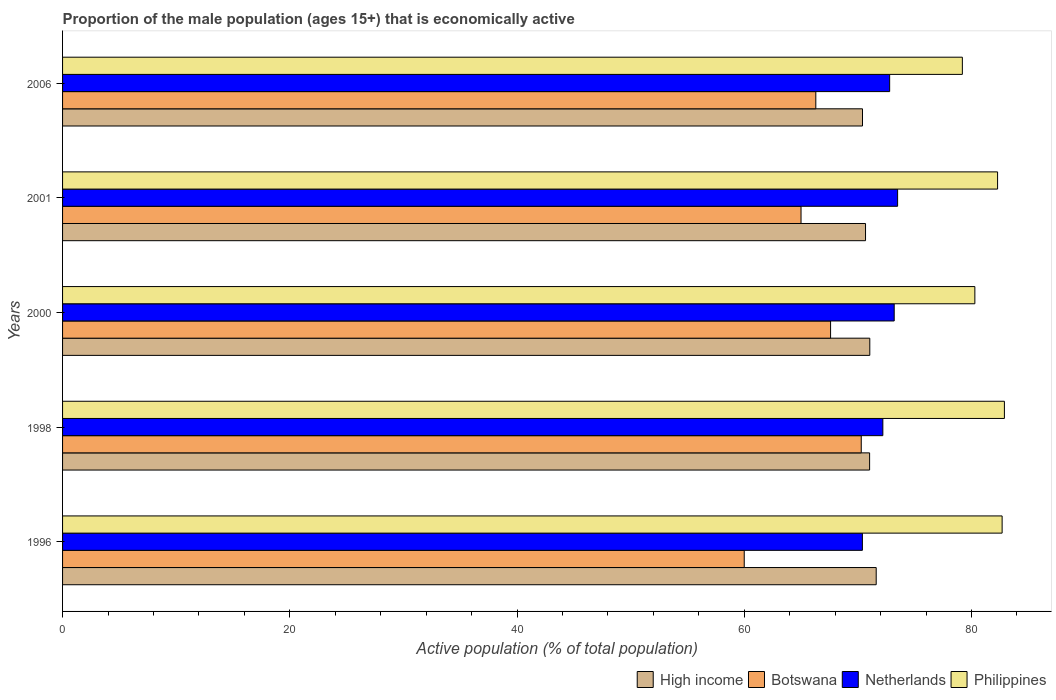How many different coloured bars are there?
Offer a terse response. 4. Are the number of bars per tick equal to the number of legend labels?
Offer a very short reply. Yes. How many bars are there on the 4th tick from the bottom?
Keep it short and to the point. 4. In how many cases, is the number of bars for a given year not equal to the number of legend labels?
Make the answer very short. 0. Across all years, what is the maximum proportion of the male population that is economically active in Philippines?
Offer a very short reply. 82.9. Across all years, what is the minimum proportion of the male population that is economically active in Netherlands?
Ensure brevity in your answer.  70.4. In which year was the proportion of the male population that is economically active in High income minimum?
Your answer should be compact. 2006. What is the total proportion of the male population that is economically active in Philippines in the graph?
Ensure brevity in your answer.  407.4. What is the difference between the proportion of the male population that is economically active in Philippines in 2000 and that in 2001?
Give a very brief answer. -2. What is the difference between the proportion of the male population that is economically active in Botswana in 2000 and the proportion of the male population that is economically active in Netherlands in 2001?
Make the answer very short. -5.9. What is the average proportion of the male population that is economically active in Botswana per year?
Provide a succinct answer. 65.84. In the year 2006, what is the difference between the proportion of the male population that is economically active in Botswana and proportion of the male population that is economically active in High income?
Offer a very short reply. -4.11. In how many years, is the proportion of the male population that is economically active in Botswana greater than 64 %?
Your answer should be compact. 4. What is the ratio of the proportion of the male population that is economically active in Botswana in 2000 to that in 2001?
Provide a succinct answer. 1.04. Is the proportion of the male population that is economically active in High income in 1998 less than that in 2006?
Your response must be concise. No. What is the difference between the highest and the second highest proportion of the male population that is economically active in Botswana?
Give a very brief answer. 2.7. What is the difference between the highest and the lowest proportion of the male population that is economically active in High income?
Ensure brevity in your answer.  1.21. In how many years, is the proportion of the male population that is economically active in Netherlands greater than the average proportion of the male population that is economically active in Netherlands taken over all years?
Give a very brief answer. 3. Is the sum of the proportion of the male population that is economically active in High income in 1998 and 2006 greater than the maximum proportion of the male population that is economically active in Philippines across all years?
Provide a short and direct response. Yes. Is it the case that in every year, the sum of the proportion of the male population that is economically active in Botswana and proportion of the male population that is economically active in High income is greater than the sum of proportion of the male population that is economically active in Philippines and proportion of the male population that is economically active in Netherlands?
Keep it short and to the point. No. What does the 1st bar from the top in 2000 represents?
Keep it short and to the point. Philippines. Are all the bars in the graph horizontal?
Make the answer very short. Yes. How many years are there in the graph?
Make the answer very short. 5. Are the values on the major ticks of X-axis written in scientific E-notation?
Your answer should be very brief. No. Does the graph contain any zero values?
Make the answer very short. No. Where does the legend appear in the graph?
Keep it short and to the point. Bottom right. How many legend labels are there?
Keep it short and to the point. 4. How are the legend labels stacked?
Ensure brevity in your answer.  Horizontal. What is the title of the graph?
Ensure brevity in your answer.  Proportion of the male population (ages 15+) that is economically active. What is the label or title of the X-axis?
Ensure brevity in your answer.  Active population (% of total population). What is the Active population (% of total population) in High income in 1996?
Your response must be concise. 71.62. What is the Active population (% of total population) in Botswana in 1996?
Offer a very short reply. 60. What is the Active population (% of total population) of Netherlands in 1996?
Provide a short and direct response. 70.4. What is the Active population (% of total population) of Philippines in 1996?
Make the answer very short. 82.7. What is the Active population (% of total population) of High income in 1998?
Provide a succinct answer. 71.04. What is the Active population (% of total population) in Botswana in 1998?
Your answer should be very brief. 70.3. What is the Active population (% of total population) in Netherlands in 1998?
Give a very brief answer. 72.2. What is the Active population (% of total population) in Philippines in 1998?
Offer a very short reply. 82.9. What is the Active population (% of total population) of High income in 2000?
Offer a terse response. 71.05. What is the Active population (% of total population) in Botswana in 2000?
Give a very brief answer. 67.6. What is the Active population (% of total population) in Netherlands in 2000?
Keep it short and to the point. 73.2. What is the Active population (% of total population) of Philippines in 2000?
Provide a short and direct response. 80.3. What is the Active population (% of total population) of High income in 2001?
Make the answer very short. 70.68. What is the Active population (% of total population) of Netherlands in 2001?
Your response must be concise. 73.5. What is the Active population (% of total population) in Philippines in 2001?
Your answer should be very brief. 82.3. What is the Active population (% of total population) of High income in 2006?
Offer a terse response. 70.41. What is the Active population (% of total population) of Botswana in 2006?
Your answer should be compact. 66.3. What is the Active population (% of total population) in Netherlands in 2006?
Your response must be concise. 72.8. What is the Active population (% of total population) of Philippines in 2006?
Your answer should be very brief. 79.2. Across all years, what is the maximum Active population (% of total population) of High income?
Keep it short and to the point. 71.62. Across all years, what is the maximum Active population (% of total population) of Botswana?
Your answer should be compact. 70.3. Across all years, what is the maximum Active population (% of total population) in Netherlands?
Your response must be concise. 73.5. Across all years, what is the maximum Active population (% of total population) of Philippines?
Your answer should be compact. 82.9. Across all years, what is the minimum Active population (% of total population) in High income?
Offer a very short reply. 70.41. Across all years, what is the minimum Active population (% of total population) in Botswana?
Make the answer very short. 60. Across all years, what is the minimum Active population (% of total population) in Netherlands?
Your answer should be compact. 70.4. Across all years, what is the minimum Active population (% of total population) in Philippines?
Your answer should be very brief. 79.2. What is the total Active population (% of total population) of High income in the graph?
Make the answer very short. 354.79. What is the total Active population (% of total population) of Botswana in the graph?
Keep it short and to the point. 329.2. What is the total Active population (% of total population) in Netherlands in the graph?
Give a very brief answer. 362.1. What is the total Active population (% of total population) in Philippines in the graph?
Ensure brevity in your answer.  407.4. What is the difference between the Active population (% of total population) of High income in 1996 and that in 1998?
Provide a short and direct response. 0.58. What is the difference between the Active population (% of total population) in High income in 1996 and that in 2000?
Ensure brevity in your answer.  0.56. What is the difference between the Active population (% of total population) in Netherlands in 1996 and that in 2000?
Provide a short and direct response. -2.8. What is the difference between the Active population (% of total population) of High income in 1996 and that in 2001?
Keep it short and to the point. 0.94. What is the difference between the Active population (% of total population) of Philippines in 1996 and that in 2001?
Ensure brevity in your answer.  0.4. What is the difference between the Active population (% of total population) in High income in 1996 and that in 2006?
Provide a succinct answer. 1.21. What is the difference between the Active population (% of total population) in Botswana in 1996 and that in 2006?
Provide a short and direct response. -6.3. What is the difference between the Active population (% of total population) in Netherlands in 1996 and that in 2006?
Your answer should be compact. -2.4. What is the difference between the Active population (% of total population) in Philippines in 1996 and that in 2006?
Ensure brevity in your answer.  3.5. What is the difference between the Active population (% of total population) of High income in 1998 and that in 2000?
Offer a terse response. -0.02. What is the difference between the Active population (% of total population) of Netherlands in 1998 and that in 2000?
Offer a very short reply. -1. What is the difference between the Active population (% of total population) of Philippines in 1998 and that in 2000?
Make the answer very short. 2.6. What is the difference between the Active population (% of total population) of High income in 1998 and that in 2001?
Your answer should be compact. 0.36. What is the difference between the Active population (% of total population) of Botswana in 1998 and that in 2001?
Offer a terse response. 5.3. What is the difference between the Active population (% of total population) of Philippines in 1998 and that in 2001?
Give a very brief answer. 0.6. What is the difference between the Active population (% of total population) of High income in 1998 and that in 2006?
Your answer should be very brief. 0.63. What is the difference between the Active population (% of total population) in Botswana in 1998 and that in 2006?
Your answer should be compact. 4. What is the difference between the Active population (% of total population) of High income in 2000 and that in 2001?
Offer a terse response. 0.38. What is the difference between the Active population (% of total population) of Botswana in 2000 and that in 2001?
Provide a short and direct response. 2.6. What is the difference between the Active population (% of total population) of Philippines in 2000 and that in 2001?
Make the answer very short. -2. What is the difference between the Active population (% of total population) in High income in 2000 and that in 2006?
Your response must be concise. 0.64. What is the difference between the Active population (% of total population) in Botswana in 2000 and that in 2006?
Your response must be concise. 1.3. What is the difference between the Active population (% of total population) of Netherlands in 2000 and that in 2006?
Your response must be concise. 0.4. What is the difference between the Active population (% of total population) of High income in 2001 and that in 2006?
Ensure brevity in your answer.  0.27. What is the difference between the Active population (% of total population) in Philippines in 2001 and that in 2006?
Offer a terse response. 3.1. What is the difference between the Active population (% of total population) of High income in 1996 and the Active population (% of total population) of Botswana in 1998?
Your answer should be compact. 1.32. What is the difference between the Active population (% of total population) of High income in 1996 and the Active population (% of total population) of Netherlands in 1998?
Provide a short and direct response. -0.58. What is the difference between the Active population (% of total population) of High income in 1996 and the Active population (% of total population) of Philippines in 1998?
Offer a terse response. -11.28. What is the difference between the Active population (% of total population) in Botswana in 1996 and the Active population (% of total population) in Netherlands in 1998?
Your response must be concise. -12.2. What is the difference between the Active population (% of total population) of Botswana in 1996 and the Active population (% of total population) of Philippines in 1998?
Give a very brief answer. -22.9. What is the difference between the Active population (% of total population) of Netherlands in 1996 and the Active population (% of total population) of Philippines in 1998?
Provide a succinct answer. -12.5. What is the difference between the Active population (% of total population) in High income in 1996 and the Active population (% of total population) in Botswana in 2000?
Offer a very short reply. 4.02. What is the difference between the Active population (% of total population) of High income in 1996 and the Active population (% of total population) of Netherlands in 2000?
Offer a terse response. -1.58. What is the difference between the Active population (% of total population) of High income in 1996 and the Active population (% of total population) of Philippines in 2000?
Give a very brief answer. -8.68. What is the difference between the Active population (% of total population) of Botswana in 1996 and the Active population (% of total population) of Netherlands in 2000?
Give a very brief answer. -13.2. What is the difference between the Active population (% of total population) of Botswana in 1996 and the Active population (% of total population) of Philippines in 2000?
Provide a succinct answer. -20.3. What is the difference between the Active population (% of total population) in High income in 1996 and the Active population (% of total population) in Botswana in 2001?
Offer a very short reply. 6.62. What is the difference between the Active population (% of total population) in High income in 1996 and the Active population (% of total population) in Netherlands in 2001?
Offer a very short reply. -1.88. What is the difference between the Active population (% of total population) in High income in 1996 and the Active population (% of total population) in Philippines in 2001?
Ensure brevity in your answer.  -10.68. What is the difference between the Active population (% of total population) in Botswana in 1996 and the Active population (% of total population) in Netherlands in 2001?
Offer a very short reply. -13.5. What is the difference between the Active population (% of total population) of Botswana in 1996 and the Active population (% of total population) of Philippines in 2001?
Keep it short and to the point. -22.3. What is the difference between the Active population (% of total population) in Netherlands in 1996 and the Active population (% of total population) in Philippines in 2001?
Offer a terse response. -11.9. What is the difference between the Active population (% of total population) in High income in 1996 and the Active population (% of total population) in Botswana in 2006?
Your response must be concise. 5.32. What is the difference between the Active population (% of total population) in High income in 1996 and the Active population (% of total population) in Netherlands in 2006?
Give a very brief answer. -1.18. What is the difference between the Active population (% of total population) of High income in 1996 and the Active population (% of total population) of Philippines in 2006?
Your answer should be very brief. -7.58. What is the difference between the Active population (% of total population) of Botswana in 1996 and the Active population (% of total population) of Netherlands in 2006?
Offer a very short reply. -12.8. What is the difference between the Active population (% of total population) in Botswana in 1996 and the Active population (% of total population) in Philippines in 2006?
Your answer should be compact. -19.2. What is the difference between the Active population (% of total population) of Netherlands in 1996 and the Active population (% of total population) of Philippines in 2006?
Ensure brevity in your answer.  -8.8. What is the difference between the Active population (% of total population) of High income in 1998 and the Active population (% of total population) of Botswana in 2000?
Keep it short and to the point. 3.44. What is the difference between the Active population (% of total population) of High income in 1998 and the Active population (% of total population) of Netherlands in 2000?
Your answer should be very brief. -2.16. What is the difference between the Active population (% of total population) of High income in 1998 and the Active population (% of total population) of Philippines in 2000?
Your answer should be very brief. -9.26. What is the difference between the Active population (% of total population) of Botswana in 1998 and the Active population (% of total population) of Netherlands in 2000?
Offer a terse response. -2.9. What is the difference between the Active population (% of total population) in Netherlands in 1998 and the Active population (% of total population) in Philippines in 2000?
Make the answer very short. -8.1. What is the difference between the Active population (% of total population) of High income in 1998 and the Active population (% of total population) of Botswana in 2001?
Give a very brief answer. 6.04. What is the difference between the Active population (% of total population) of High income in 1998 and the Active population (% of total population) of Netherlands in 2001?
Provide a short and direct response. -2.46. What is the difference between the Active population (% of total population) in High income in 1998 and the Active population (% of total population) in Philippines in 2001?
Offer a terse response. -11.26. What is the difference between the Active population (% of total population) of Botswana in 1998 and the Active population (% of total population) of Netherlands in 2001?
Offer a terse response. -3.2. What is the difference between the Active population (% of total population) in Netherlands in 1998 and the Active population (% of total population) in Philippines in 2001?
Give a very brief answer. -10.1. What is the difference between the Active population (% of total population) in High income in 1998 and the Active population (% of total population) in Botswana in 2006?
Give a very brief answer. 4.74. What is the difference between the Active population (% of total population) in High income in 1998 and the Active population (% of total population) in Netherlands in 2006?
Give a very brief answer. -1.76. What is the difference between the Active population (% of total population) in High income in 1998 and the Active population (% of total population) in Philippines in 2006?
Provide a short and direct response. -8.16. What is the difference between the Active population (% of total population) in Botswana in 1998 and the Active population (% of total population) in Philippines in 2006?
Offer a terse response. -8.9. What is the difference between the Active population (% of total population) in High income in 2000 and the Active population (% of total population) in Botswana in 2001?
Ensure brevity in your answer.  6.05. What is the difference between the Active population (% of total population) in High income in 2000 and the Active population (% of total population) in Netherlands in 2001?
Give a very brief answer. -2.45. What is the difference between the Active population (% of total population) of High income in 2000 and the Active population (% of total population) of Philippines in 2001?
Offer a terse response. -11.25. What is the difference between the Active population (% of total population) in Botswana in 2000 and the Active population (% of total population) in Netherlands in 2001?
Ensure brevity in your answer.  -5.9. What is the difference between the Active population (% of total population) of Botswana in 2000 and the Active population (% of total population) of Philippines in 2001?
Your response must be concise. -14.7. What is the difference between the Active population (% of total population) of Netherlands in 2000 and the Active population (% of total population) of Philippines in 2001?
Your answer should be very brief. -9.1. What is the difference between the Active population (% of total population) of High income in 2000 and the Active population (% of total population) of Botswana in 2006?
Offer a terse response. 4.75. What is the difference between the Active population (% of total population) in High income in 2000 and the Active population (% of total population) in Netherlands in 2006?
Keep it short and to the point. -1.75. What is the difference between the Active population (% of total population) in High income in 2000 and the Active population (% of total population) in Philippines in 2006?
Offer a terse response. -8.15. What is the difference between the Active population (% of total population) in Netherlands in 2000 and the Active population (% of total population) in Philippines in 2006?
Provide a succinct answer. -6. What is the difference between the Active population (% of total population) in High income in 2001 and the Active population (% of total population) in Botswana in 2006?
Give a very brief answer. 4.38. What is the difference between the Active population (% of total population) in High income in 2001 and the Active population (% of total population) in Netherlands in 2006?
Offer a very short reply. -2.12. What is the difference between the Active population (% of total population) of High income in 2001 and the Active population (% of total population) of Philippines in 2006?
Keep it short and to the point. -8.52. What is the difference between the Active population (% of total population) in Botswana in 2001 and the Active population (% of total population) in Netherlands in 2006?
Ensure brevity in your answer.  -7.8. What is the difference between the Active population (% of total population) of Netherlands in 2001 and the Active population (% of total population) of Philippines in 2006?
Your response must be concise. -5.7. What is the average Active population (% of total population) of High income per year?
Give a very brief answer. 70.96. What is the average Active population (% of total population) in Botswana per year?
Give a very brief answer. 65.84. What is the average Active population (% of total population) of Netherlands per year?
Ensure brevity in your answer.  72.42. What is the average Active population (% of total population) in Philippines per year?
Give a very brief answer. 81.48. In the year 1996, what is the difference between the Active population (% of total population) of High income and Active population (% of total population) of Botswana?
Your response must be concise. 11.62. In the year 1996, what is the difference between the Active population (% of total population) in High income and Active population (% of total population) in Netherlands?
Provide a succinct answer. 1.22. In the year 1996, what is the difference between the Active population (% of total population) in High income and Active population (% of total population) in Philippines?
Offer a very short reply. -11.08. In the year 1996, what is the difference between the Active population (% of total population) of Botswana and Active population (% of total population) of Netherlands?
Keep it short and to the point. -10.4. In the year 1996, what is the difference between the Active population (% of total population) of Botswana and Active population (% of total population) of Philippines?
Your answer should be very brief. -22.7. In the year 1996, what is the difference between the Active population (% of total population) of Netherlands and Active population (% of total population) of Philippines?
Ensure brevity in your answer.  -12.3. In the year 1998, what is the difference between the Active population (% of total population) of High income and Active population (% of total population) of Botswana?
Make the answer very short. 0.74. In the year 1998, what is the difference between the Active population (% of total population) in High income and Active population (% of total population) in Netherlands?
Your answer should be compact. -1.16. In the year 1998, what is the difference between the Active population (% of total population) of High income and Active population (% of total population) of Philippines?
Keep it short and to the point. -11.86. In the year 1998, what is the difference between the Active population (% of total population) of Botswana and Active population (% of total population) of Netherlands?
Offer a terse response. -1.9. In the year 1998, what is the difference between the Active population (% of total population) in Botswana and Active population (% of total population) in Philippines?
Give a very brief answer. -12.6. In the year 1998, what is the difference between the Active population (% of total population) of Netherlands and Active population (% of total population) of Philippines?
Give a very brief answer. -10.7. In the year 2000, what is the difference between the Active population (% of total population) of High income and Active population (% of total population) of Botswana?
Give a very brief answer. 3.45. In the year 2000, what is the difference between the Active population (% of total population) in High income and Active population (% of total population) in Netherlands?
Offer a terse response. -2.15. In the year 2000, what is the difference between the Active population (% of total population) in High income and Active population (% of total population) in Philippines?
Your response must be concise. -9.25. In the year 2001, what is the difference between the Active population (% of total population) in High income and Active population (% of total population) in Botswana?
Your answer should be very brief. 5.68. In the year 2001, what is the difference between the Active population (% of total population) in High income and Active population (% of total population) in Netherlands?
Your answer should be very brief. -2.82. In the year 2001, what is the difference between the Active population (% of total population) in High income and Active population (% of total population) in Philippines?
Make the answer very short. -11.62. In the year 2001, what is the difference between the Active population (% of total population) in Botswana and Active population (% of total population) in Philippines?
Offer a very short reply. -17.3. In the year 2001, what is the difference between the Active population (% of total population) of Netherlands and Active population (% of total population) of Philippines?
Offer a very short reply. -8.8. In the year 2006, what is the difference between the Active population (% of total population) in High income and Active population (% of total population) in Botswana?
Offer a terse response. 4.11. In the year 2006, what is the difference between the Active population (% of total population) in High income and Active population (% of total population) in Netherlands?
Offer a terse response. -2.39. In the year 2006, what is the difference between the Active population (% of total population) in High income and Active population (% of total population) in Philippines?
Give a very brief answer. -8.79. In the year 2006, what is the difference between the Active population (% of total population) in Botswana and Active population (% of total population) in Netherlands?
Provide a short and direct response. -6.5. In the year 2006, what is the difference between the Active population (% of total population) in Botswana and Active population (% of total population) in Philippines?
Give a very brief answer. -12.9. In the year 2006, what is the difference between the Active population (% of total population) of Netherlands and Active population (% of total population) of Philippines?
Ensure brevity in your answer.  -6.4. What is the ratio of the Active population (% of total population) of High income in 1996 to that in 1998?
Your response must be concise. 1.01. What is the ratio of the Active population (% of total population) of Botswana in 1996 to that in 1998?
Give a very brief answer. 0.85. What is the ratio of the Active population (% of total population) of Netherlands in 1996 to that in 1998?
Your answer should be very brief. 0.98. What is the ratio of the Active population (% of total population) of Philippines in 1996 to that in 1998?
Offer a terse response. 1. What is the ratio of the Active population (% of total population) in High income in 1996 to that in 2000?
Offer a very short reply. 1.01. What is the ratio of the Active population (% of total population) in Botswana in 1996 to that in 2000?
Offer a very short reply. 0.89. What is the ratio of the Active population (% of total population) of Netherlands in 1996 to that in 2000?
Give a very brief answer. 0.96. What is the ratio of the Active population (% of total population) of Philippines in 1996 to that in 2000?
Offer a very short reply. 1.03. What is the ratio of the Active population (% of total population) of High income in 1996 to that in 2001?
Ensure brevity in your answer.  1.01. What is the ratio of the Active population (% of total population) of Botswana in 1996 to that in 2001?
Ensure brevity in your answer.  0.92. What is the ratio of the Active population (% of total population) of Netherlands in 1996 to that in 2001?
Offer a very short reply. 0.96. What is the ratio of the Active population (% of total population) in Philippines in 1996 to that in 2001?
Offer a very short reply. 1. What is the ratio of the Active population (% of total population) of High income in 1996 to that in 2006?
Make the answer very short. 1.02. What is the ratio of the Active population (% of total population) in Botswana in 1996 to that in 2006?
Give a very brief answer. 0.91. What is the ratio of the Active population (% of total population) in Netherlands in 1996 to that in 2006?
Your response must be concise. 0.97. What is the ratio of the Active population (% of total population) in Philippines in 1996 to that in 2006?
Your answer should be compact. 1.04. What is the ratio of the Active population (% of total population) of High income in 1998 to that in 2000?
Give a very brief answer. 1. What is the ratio of the Active population (% of total population) of Botswana in 1998 to that in 2000?
Ensure brevity in your answer.  1.04. What is the ratio of the Active population (% of total population) of Netherlands in 1998 to that in 2000?
Your answer should be very brief. 0.99. What is the ratio of the Active population (% of total population) of Philippines in 1998 to that in 2000?
Your answer should be compact. 1.03. What is the ratio of the Active population (% of total population) in Botswana in 1998 to that in 2001?
Make the answer very short. 1.08. What is the ratio of the Active population (% of total population) of Netherlands in 1998 to that in 2001?
Offer a very short reply. 0.98. What is the ratio of the Active population (% of total population) of Philippines in 1998 to that in 2001?
Make the answer very short. 1.01. What is the ratio of the Active population (% of total population) of High income in 1998 to that in 2006?
Keep it short and to the point. 1.01. What is the ratio of the Active population (% of total population) in Botswana in 1998 to that in 2006?
Provide a succinct answer. 1.06. What is the ratio of the Active population (% of total population) in Philippines in 1998 to that in 2006?
Offer a terse response. 1.05. What is the ratio of the Active population (% of total population) in Philippines in 2000 to that in 2001?
Make the answer very short. 0.98. What is the ratio of the Active population (% of total population) in High income in 2000 to that in 2006?
Provide a succinct answer. 1.01. What is the ratio of the Active population (% of total population) of Botswana in 2000 to that in 2006?
Make the answer very short. 1.02. What is the ratio of the Active population (% of total population) of Netherlands in 2000 to that in 2006?
Make the answer very short. 1.01. What is the ratio of the Active population (% of total population) of Philippines in 2000 to that in 2006?
Keep it short and to the point. 1.01. What is the ratio of the Active population (% of total population) in Botswana in 2001 to that in 2006?
Your answer should be compact. 0.98. What is the ratio of the Active population (% of total population) in Netherlands in 2001 to that in 2006?
Provide a succinct answer. 1.01. What is the ratio of the Active population (% of total population) of Philippines in 2001 to that in 2006?
Offer a terse response. 1.04. What is the difference between the highest and the second highest Active population (% of total population) in High income?
Provide a short and direct response. 0.56. What is the difference between the highest and the second highest Active population (% of total population) of Botswana?
Your answer should be very brief. 2.7. What is the difference between the highest and the second highest Active population (% of total population) in Netherlands?
Your response must be concise. 0.3. What is the difference between the highest and the lowest Active population (% of total population) of High income?
Provide a succinct answer. 1.21. What is the difference between the highest and the lowest Active population (% of total population) in Netherlands?
Your answer should be very brief. 3.1. What is the difference between the highest and the lowest Active population (% of total population) of Philippines?
Give a very brief answer. 3.7. 